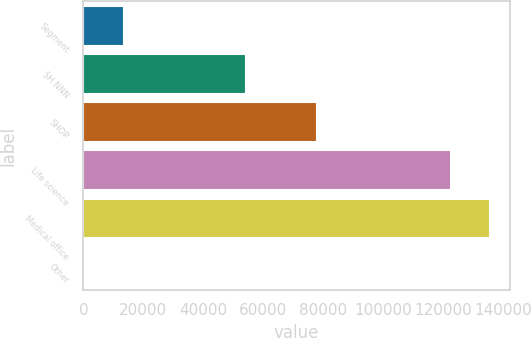<chart> <loc_0><loc_0><loc_500><loc_500><bar_chart><fcel>Segment<fcel>SH NNN<fcel>SHOP<fcel>Life science<fcel>Medical office<fcel>Other<nl><fcel>13135.4<fcel>53980<fcel>77425<fcel>122319<fcel>135417<fcel>37<nl></chart> 